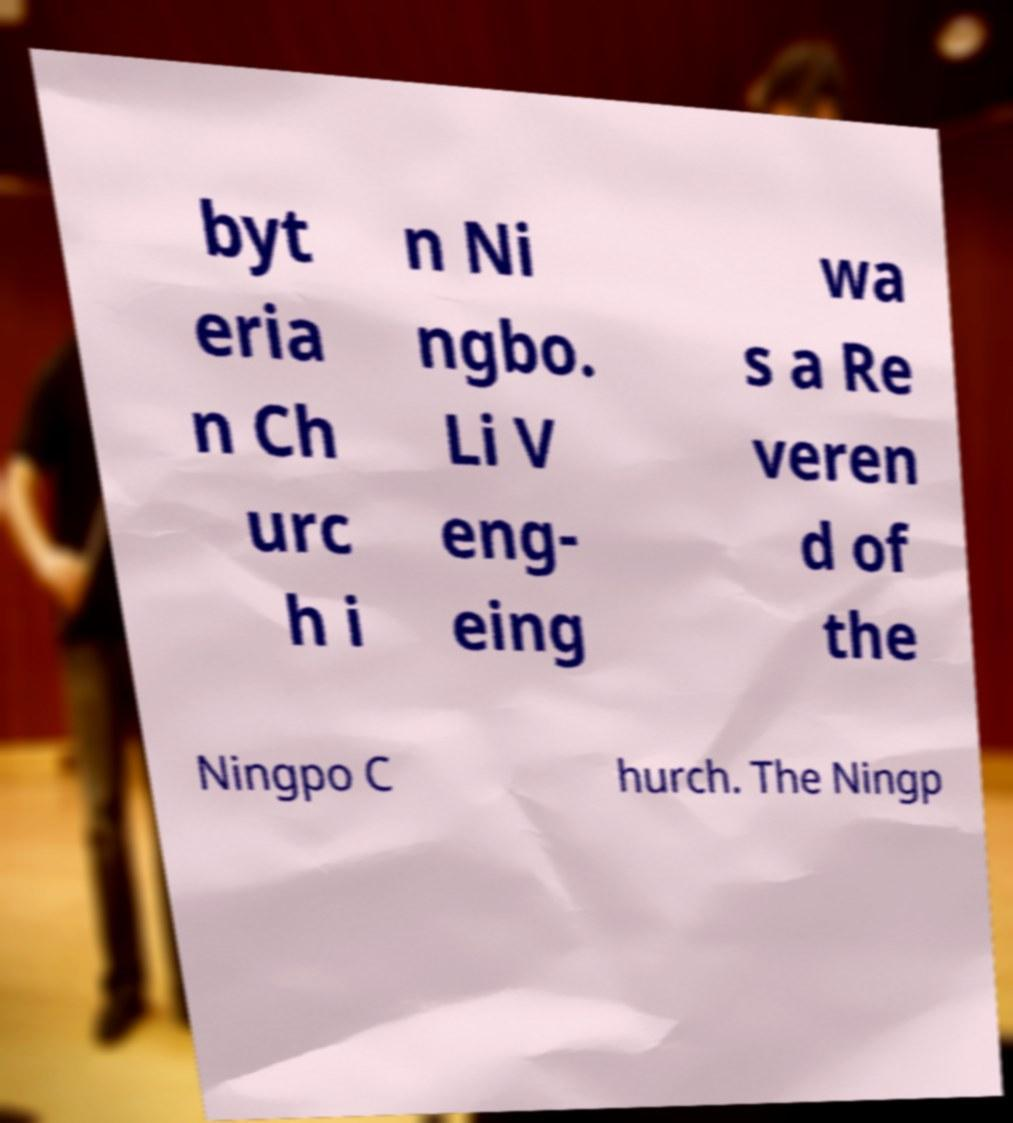Could you assist in decoding the text presented in this image and type it out clearly? byt eria n Ch urc h i n Ni ngbo. Li V eng- eing wa s a Re veren d of the Ningpo C hurch. The Ningp 